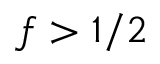<formula> <loc_0><loc_0><loc_500><loc_500>f > 1 / 2</formula> 